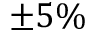Convert formula to latex. <formula><loc_0><loc_0><loc_500><loc_500>\pm 5 \%</formula> 